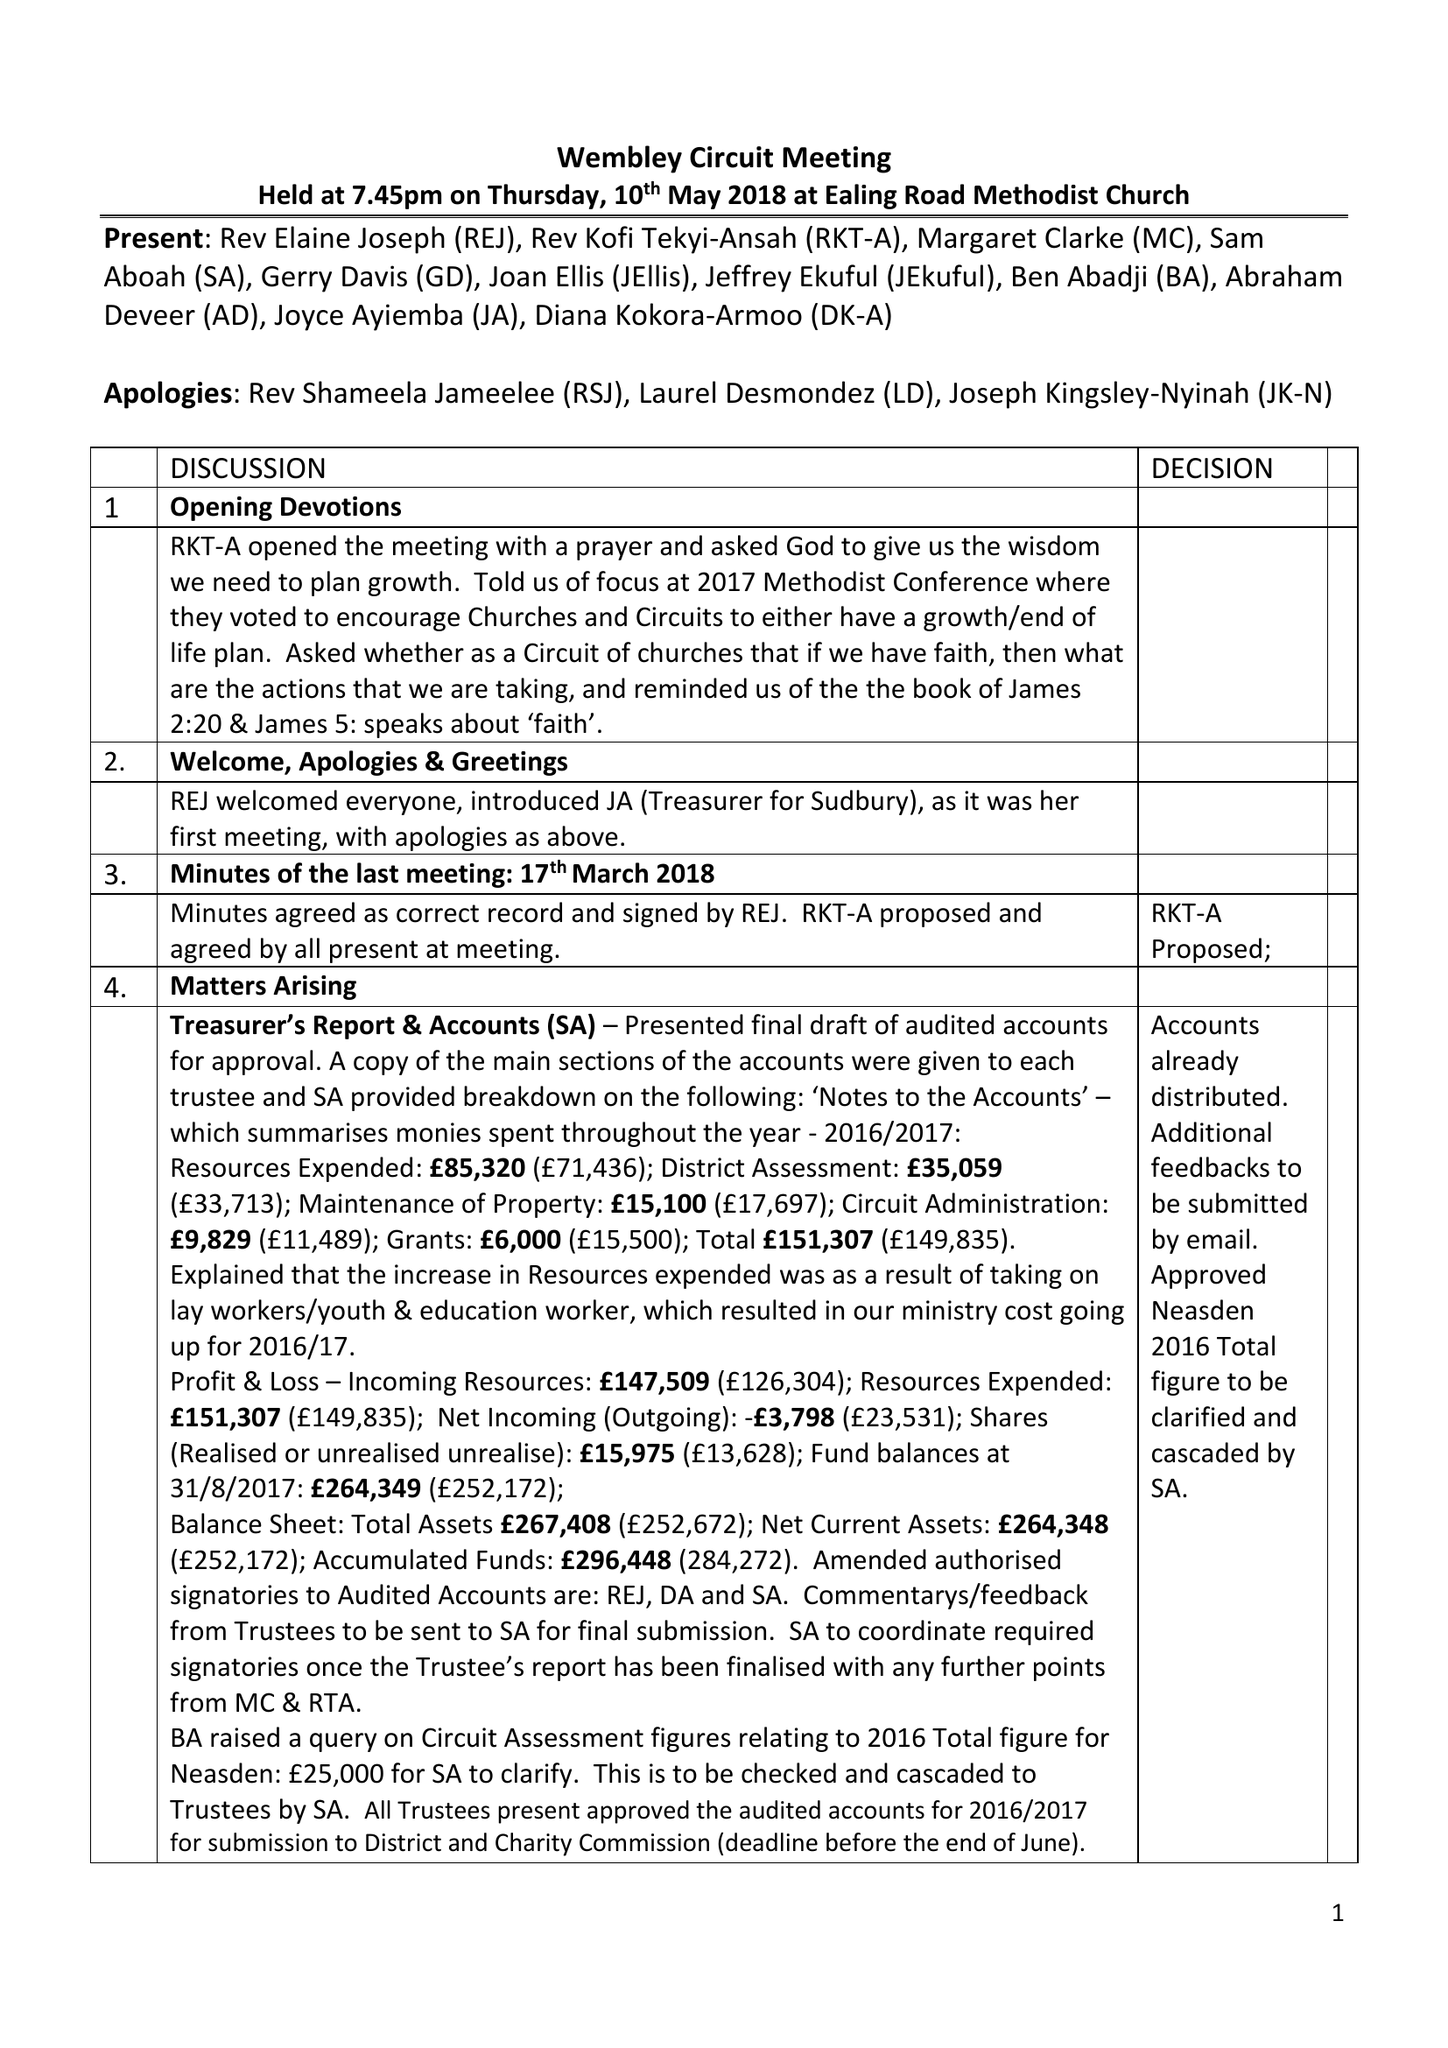What is the value for the address__street_line?
Answer the question using a single word or phrase. 10 KINGSWAY 